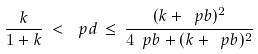Convert formula to latex. <formula><loc_0><loc_0><loc_500><loc_500>\frac { k } { 1 + k } \, < \, \ p d \, \leq \, \frac { ( k + \ p b ) ^ { 2 } } { 4 \ p b + ( k + \ p b ) ^ { 2 } }</formula> 